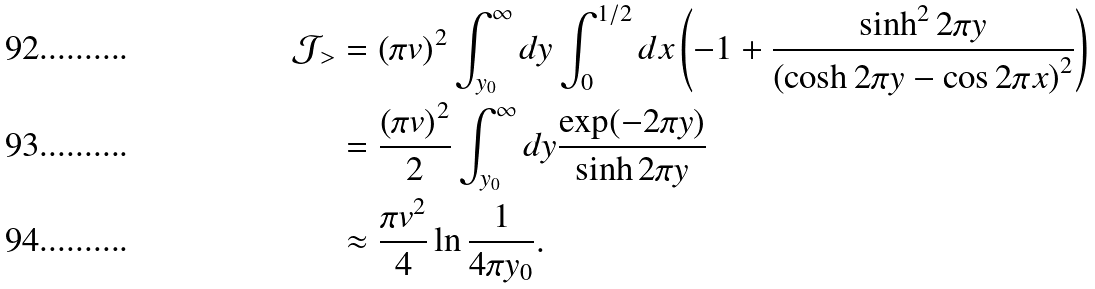Convert formula to latex. <formula><loc_0><loc_0><loc_500><loc_500>\mathcal { J } _ { > } & = \left ( \pi v \right ) ^ { 2 } \int _ { y _ { 0 } } ^ { \infty } d y \int _ { 0 } ^ { 1 / 2 } d x \left ( - 1 + \frac { \sinh ^ { 2 } 2 \pi y } { \left ( \cosh 2 \pi y - \cos 2 \pi x \right ) ^ { 2 } } \right ) \\ & = \frac { \left ( \pi v \right ) ^ { 2 } } { 2 } \int _ { y _ { 0 } } ^ { \infty } d y \frac { \exp ( - 2 \pi y ) } { \sinh 2 \pi y } \\ & \approx \frac { \pi v ^ { 2 } } { 4 } \ln \frac { 1 } { 4 \pi y _ { 0 } } .</formula> 